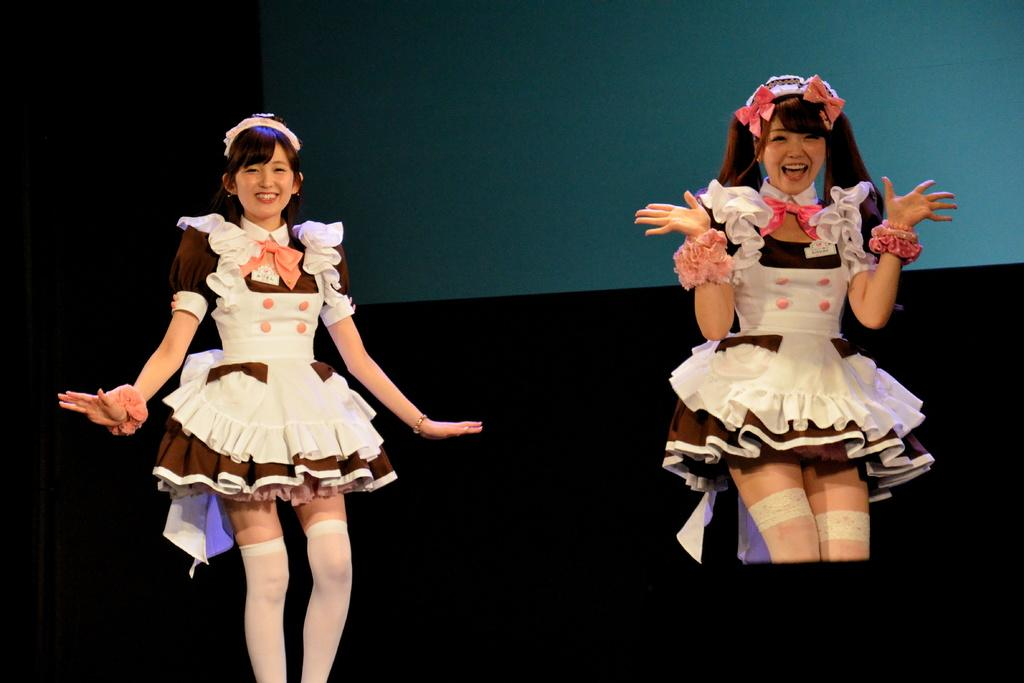How many people are in the image? There are two people in the image. What are the people doing in the image? The people are standing. What colors are the dresses worn by the people in the image? One person is wearing a white dress, one person is wearing a brown dress, and one person is wearing a peach-colored dress. What colors can be seen in the background of the image? The background of the image is black and blue. Can you see any connections between the people in the image? There is no indication of any connections between the people in the image. Are there any flies visible in the image? There are no flies present in the image. 